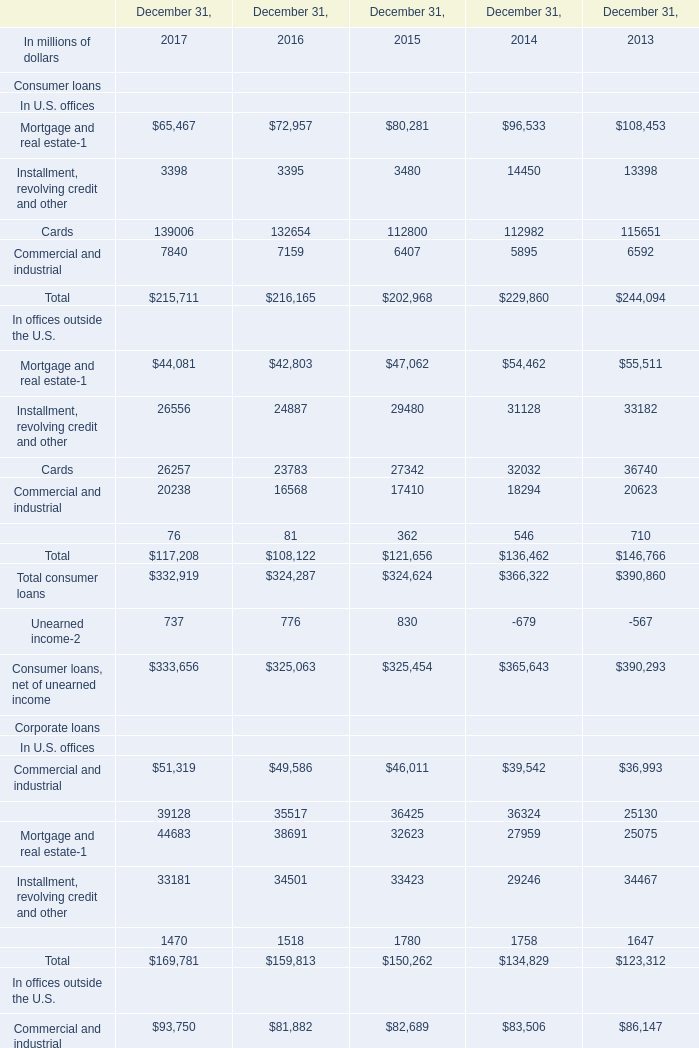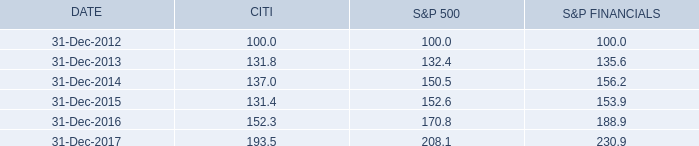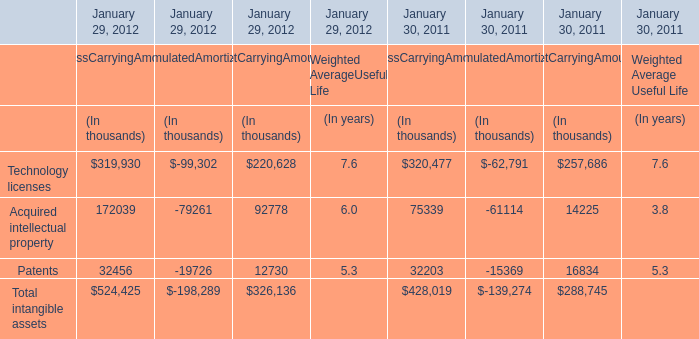what was the percentage growth of the five-year cumulative total return of s&p financials from 2015 to 2016 
Computations: ((188.9 - 153.9) / 153.9)
Answer: 0.22742. 